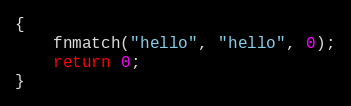<code> <loc_0><loc_0><loc_500><loc_500><_C_>{
    fnmatch("hello", "hello", 0);
    return 0;
}
</code> 